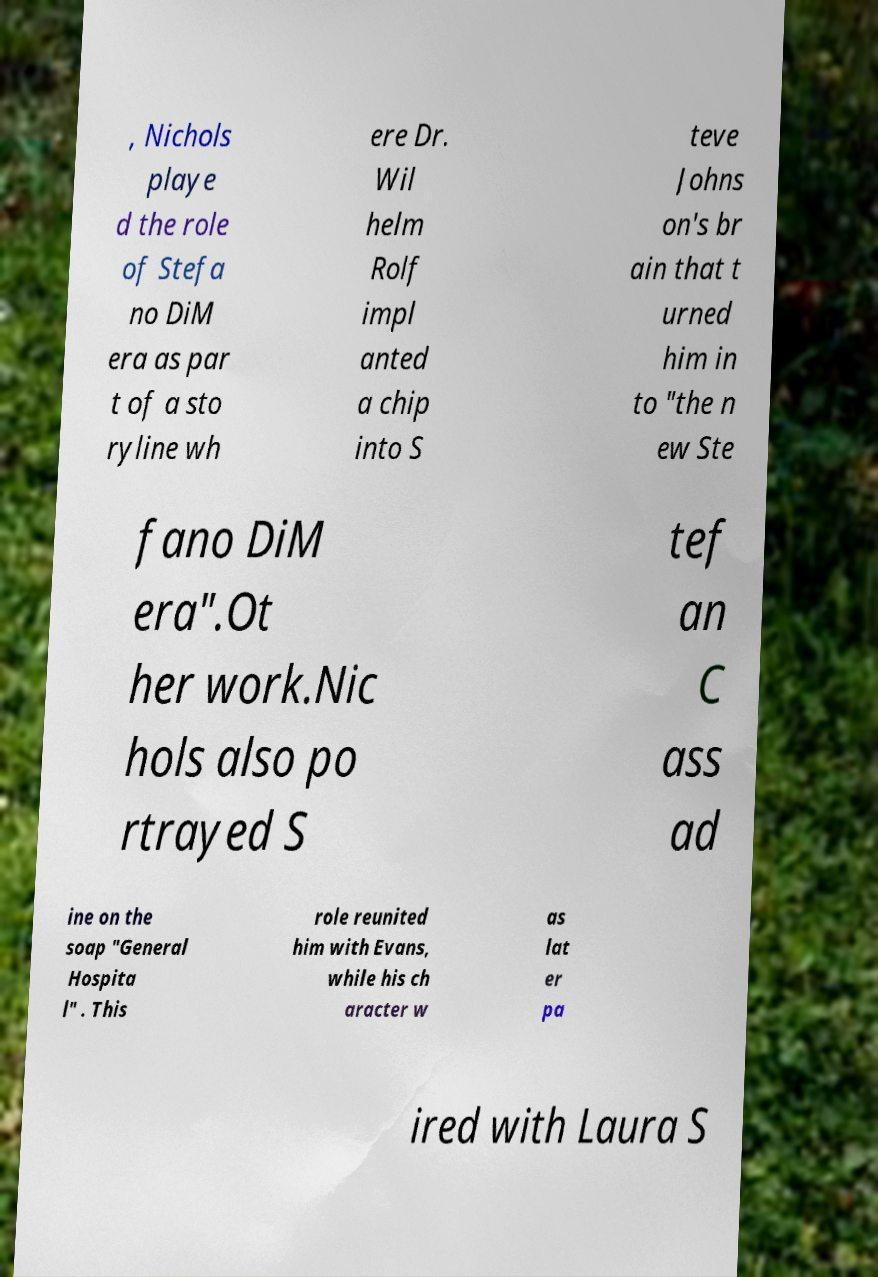For documentation purposes, I need the text within this image transcribed. Could you provide that? , Nichols playe d the role of Stefa no DiM era as par t of a sto ryline wh ere Dr. Wil helm Rolf impl anted a chip into S teve Johns on's br ain that t urned him in to "the n ew Ste fano DiM era".Ot her work.Nic hols also po rtrayed S tef an C ass ad ine on the soap "General Hospita l" . This role reunited him with Evans, while his ch aracter w as lat er pa ired with Laura S 